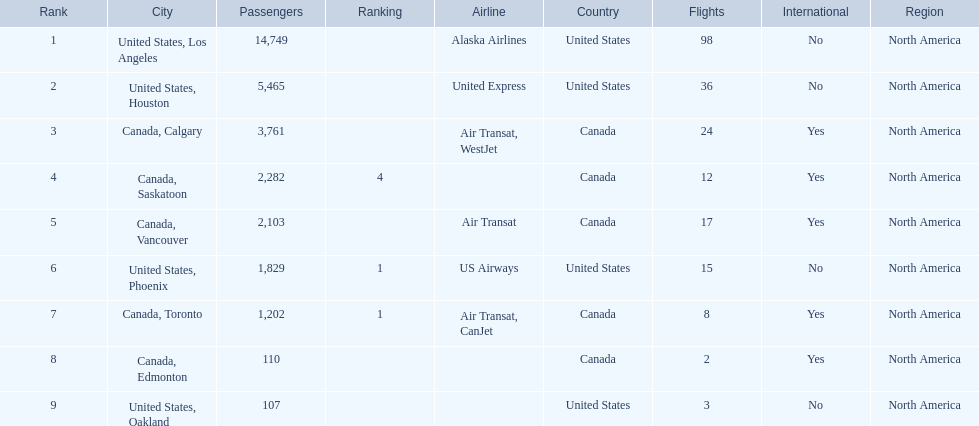Los angeles and what other city had about 19,000 passenger combined Canada, Calgary. 